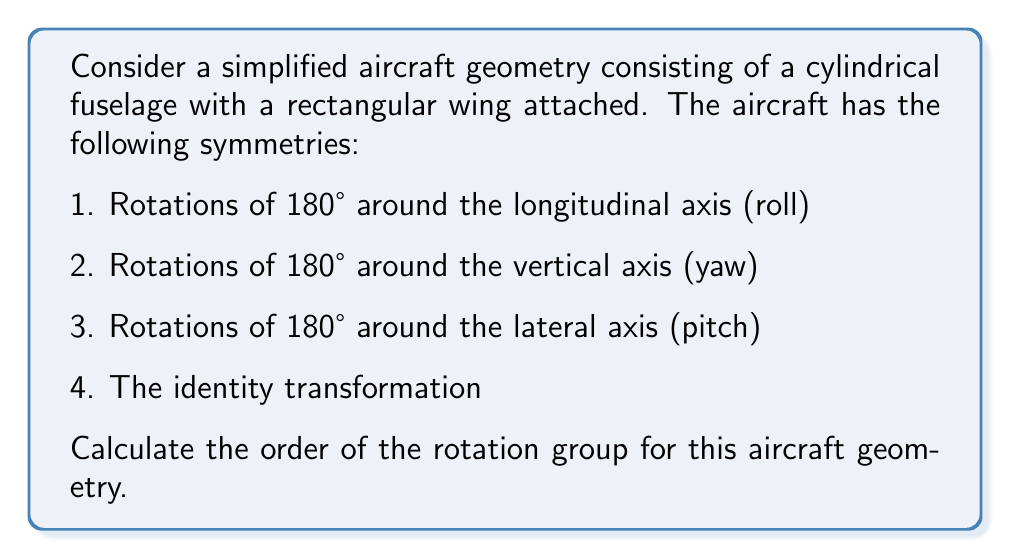What is the answer to this math problem? To determine the order of the rotation group for this aircraft geometry, we need to identify all unique rotations that preserve the symmetry of the aircraft. Let's analyze the given symmetries:

1. Identity transformation: This is always present in any group and represents no rotation.

2. 180° rotation around the longitudinal axis (roll):
   $R_x: (x, y, z) \rightarrow (x, -y, -z)$

3. 180° rotation around the vertical axis (yaw):
   $R_y: (x, y, z) \rightarrow (-x, y, -z)$

4. 180° rotation around the lateral axis (pitch):
   $R_z: (x, y, z) \rightarrow (-x, -y, z)$

Now, let's consider the compositions of these rotations:

5. $R_x \circ R_y: (x, y, z) \rightarrow (-x, -y, -z)$
   This is equivalent to a 180° rotation around the axis passing through opposite corners of the aircraft.

6. $R_y \circ R_z: (x, y, z) \rightarrow (x, -y, -z)$
   This is equivalent to $R_x$.

7. $R_x \circ R_z: (x, y, z) \rightarrow (-x, y, -z)$
   This is equivalent to $R_y$.

8. $R_x \circ R_y \circ R_z: (x, y, z) \rightarrow (x, y, z)$
   This is equivalent to the identity transformation.

We can see that there are no other unique rotations that can be formed from the given symmetries. Therefore, the rotation group for this aircraft geometry consists of 4 unique elements:

1. Identity
2. 180° rotation around the longitudinal axis (roll)
3. 180° rotation around the vertical axis (yaw)
4. 180° rotation around the lateral axis (pitch)

The order of a group is defined as the number of elements in the group. In this case, we have identified 4 unique elements in the rotation group.
Answer: The order of the rotation group for the given aircraft geometry is 4. 